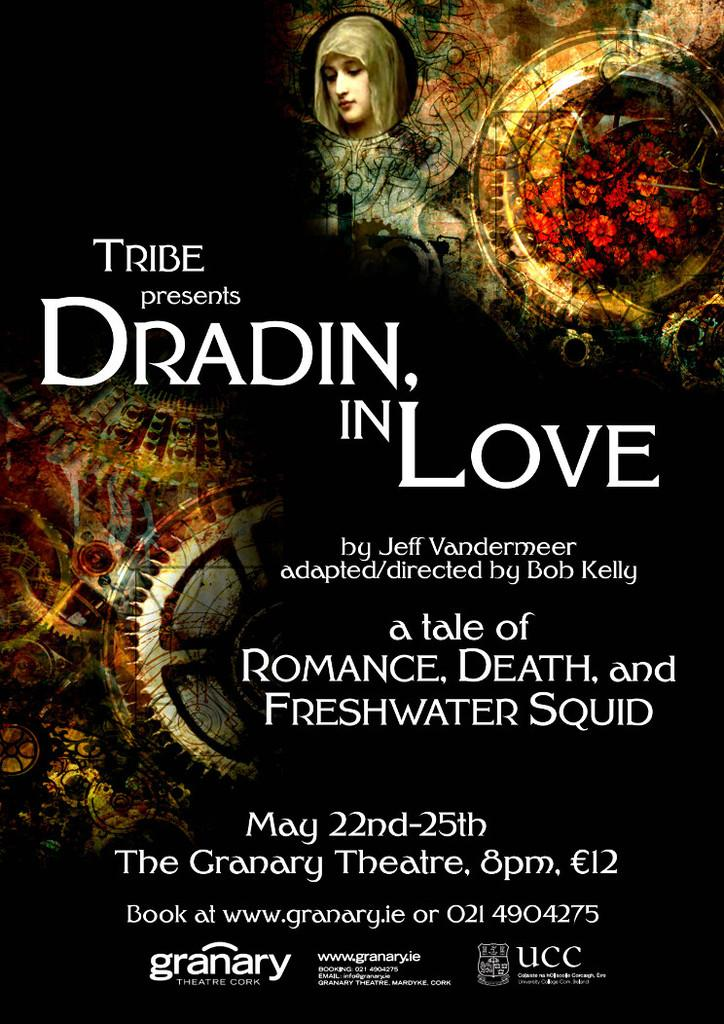<image>
Provide a brief description of the given image. The theatre production of Dradin in Love directed by Bob Kelly. 